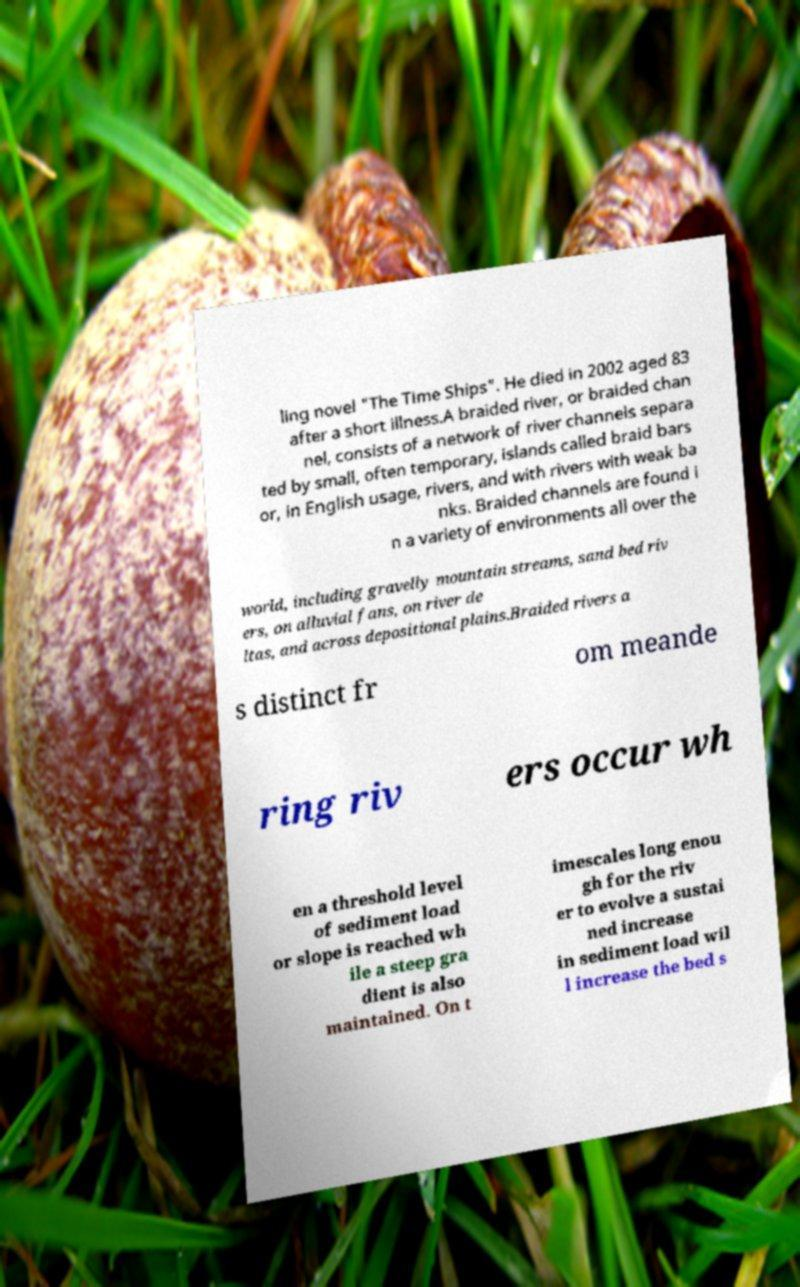For documentation purposes, I need the text within this image transcribed. Could you provide that? ling novel "The Time Ships". He died in 2002 aged 83 after a short illness.A braided river, or braided chan nel, consists of a network of river channels separa ted by small, often temporary, islands called braid bars or, in English usage, rivers, and with rivers with weak ba nks. Braided channels are found i n a variety of environments all over the world, including gravelly mountain streams, sand bed riv ers, on alluvial fans, on river de ltas, and across depositional plains.Braided rivers a s distinct fr om meande ring riv ers occur wh en a threshold level of sediment load or slope is reached wh ile a steep gra dient is also maintained. On t imescales long enou gh for the riv er to evolve a sustai ned increase in sediment load wil l increase the bed s 